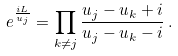Convert formula to latex. <formula><loc_0><loc_0><loc_500><loc_500>e ^ { \frac { i L } { u _ { j } } } = \prod _ { k \neq j } \frac { u _ { j } - u _ { k } + i } { u _ { j } - u _ { k } - i } \, .</formula> 